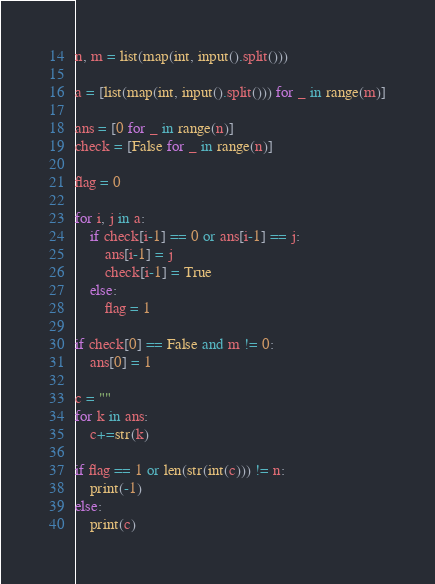<code> <loc_0><loc_0><loc_500><loc_500><_Python_>n, m = list(map(int, input().split()))

a = [list(map(int, input().split())) for _ in range(m)]

ans = [0 for _ in range(n)]
check = [False for _ in range(n)]

flag = 0

for i, j in a:
    if check[i-1] == 0 or ans[i-1] == j:
        ans[i-1] = j
        check[i-1] = True
    else:
        flag = 1
       
if check[0] == False and m != 0:
    ans[0] = 1

c = ""
for k in ans:
    c+=str(k)

if flag == 1 or len(str(int(c))) != n:
    print(-1)
else:
    print(c)</code> 